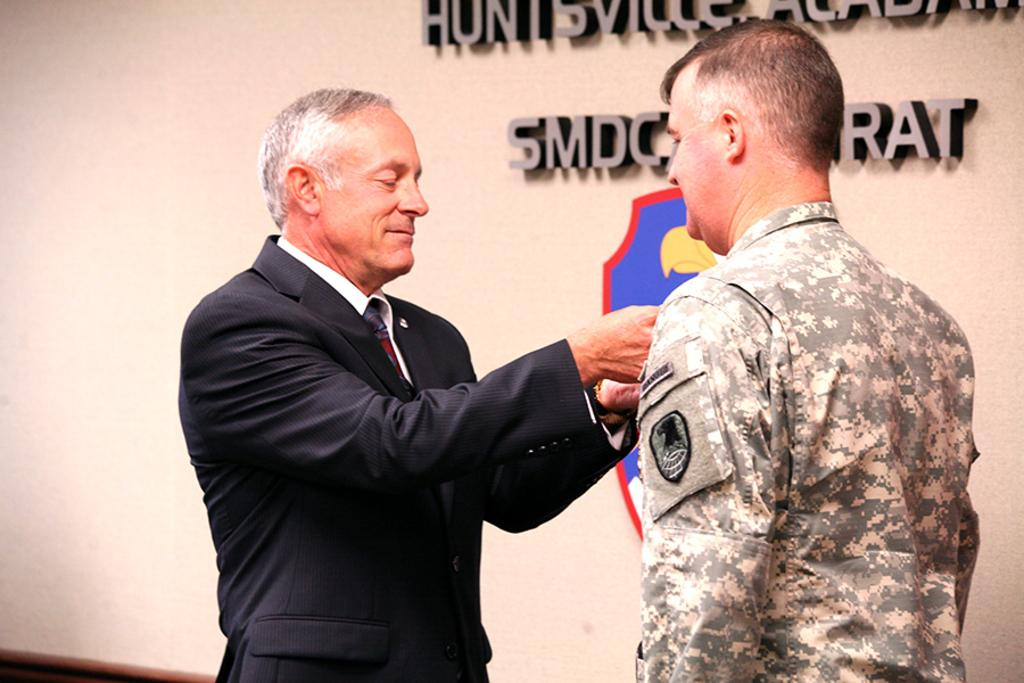How many people are in the image? There are two persons standing in the center of the image. What are the people wearing? One person is wearing a suit, and the other person is wearing a uniform. What can be seen in the background of the image? There is a wall in the background of the image. Can you tell me how many women are wearing a mark on their foreheads in the image? There are no women or marks on foreheads present in the image. What note is the person in the suit holding in the image? There is no note visible in the image. 